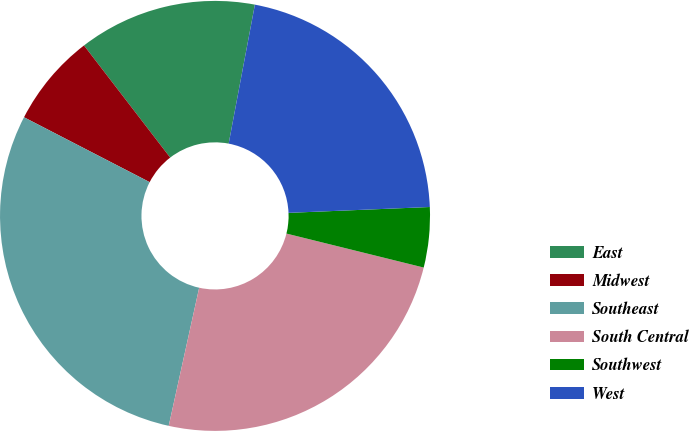<chart> <loc_0><loc_0><loc_500><loc_500><pie_chart><fcel>East<fcel>Midwest<fcel>Southeast<fcel>South Central<fcel>Southwest<fcel>West<nl><fcel>13.4%<fcel>6.98%<fcel>29.13%<fcel>24.59%<fcel>4.52%<fcel>21.37%<nl></chart> 